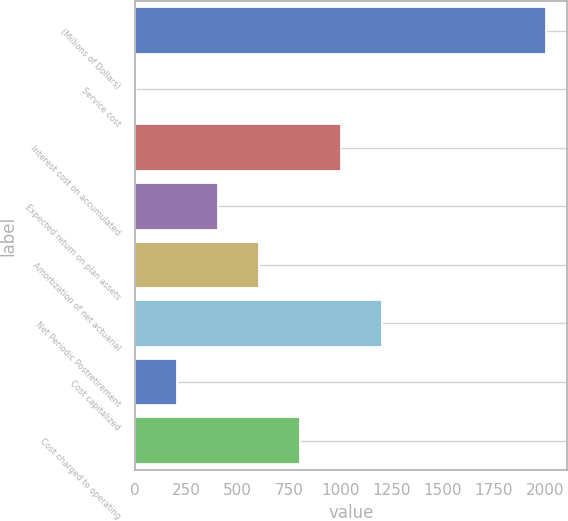Convert chart. <chart><loc_0><loc_0><loc_500><loc_500><bar_chart><fcel>(Millions of Dollars)<fcel>Service cost<fcel>Interest cost on accumulated<fcel>Expected return on plan assets<fcel>Amortization of net actuarial<fcel>Net Periodic Postretirement<fcel>Cost capitalized<fcel>Cost charged to operating<nl><fcel>2004<fcel>3<fcel>1003.5<fcel>403.2<fcel>603.3<fcel>1203.6<fcel>203.1<fcel>803.4<nl></chart> 